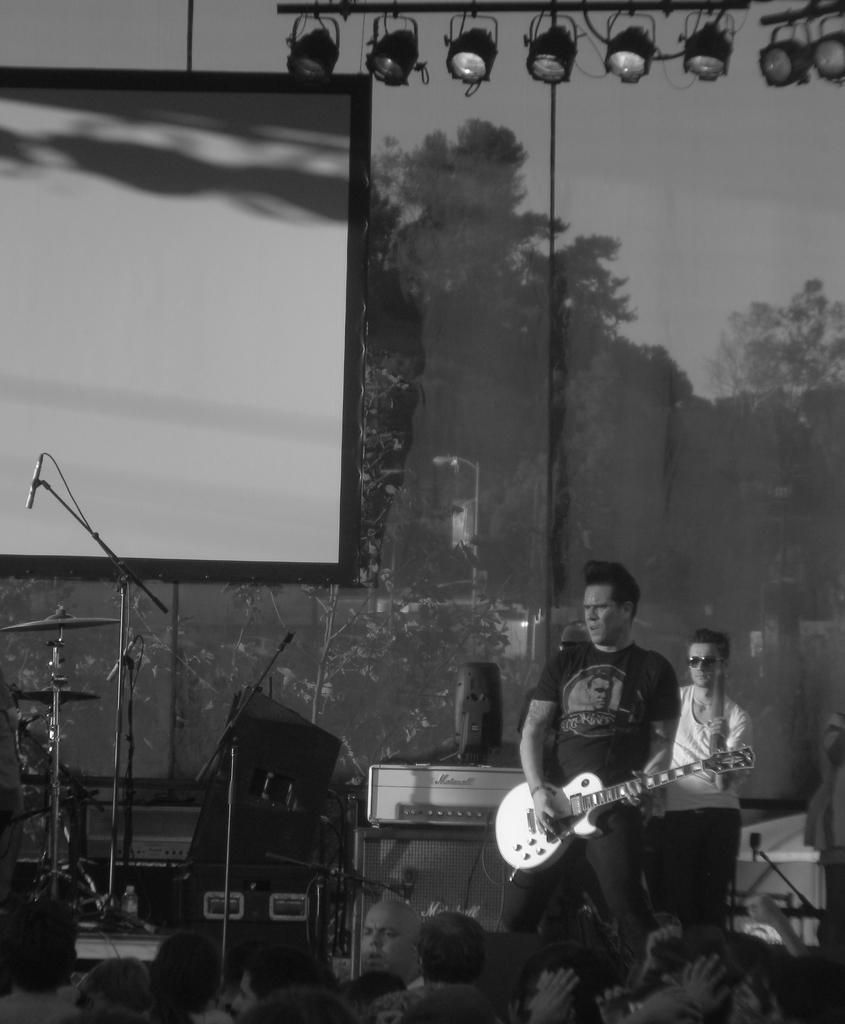Please provide a concise description of this image. In this image I can see a person standing and holding the guitar. In front of him there are group of people. At the back there is a screen and there are some trees are seen through the glass. 